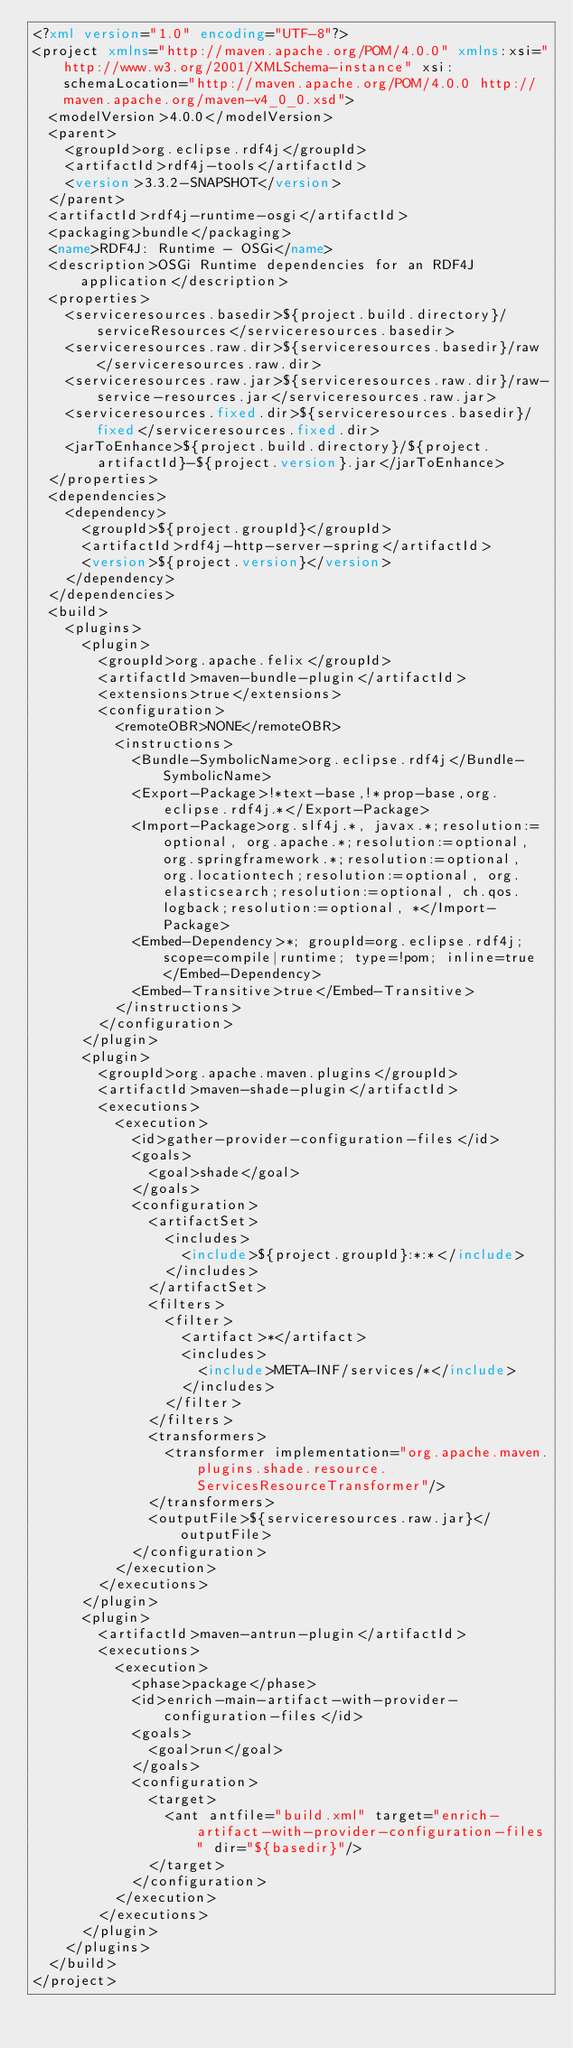Convert code to text. <code><loc_0><loc_0><loc_500><loc_500><_XML_><?xml version="1.0" encoding="UTF-8"?>
<project xmlns="http://maven.apache.org/POM/4.0.0" xmlns:xsi="http://www.w3.org/2001/XMLSchema-instance" xsi:schemaLocation="http://maven.apache.org/POM/4.0.0 http://maven.apache.org/maven-v4_0_0.xsd">
	<modelVersion>4.0.0</modelVersion>
	<parent>
		<groupId>org.eclipse.rdf4j</groupId>
		<artifactId>rdf4j-tools</artifactId>
		<version>3.3.2-SNAPSHOT</version>
	</parent>
	<artifactId>rdf4j-runtime-osgi</artifactId>
	<packaging>bundle</packaging>
	<name>RDF4J: Runtime - OSGi</name>
	<description>OSGi Runtime dependencies for an RDF4J application</description>
	<properties>
		<serviceresources.basedir>${project.build.directory}/serviceResources</serviceresources.basedir>
		<serviceresources.raw.dir>${serviceresources.basedir}/raw</serviceresources.raw.dir>
		<serviceresources.raw.jar>${serviceresources.raw.dir}/raw-service-resources.jar</serviceresources.raw.jar>
		<serviceresources.fixed.dir>${serviceresources.basedir}/fixed</serviceresources.fixed.dir>
		<jarToEnhance>${project.build.directory}/${project.artifactId}-${project.version}.jar</jarToEnhance>
	</properties>
	<dependencies>
		<dependency>
			<groupId>${project.groupId}</groupId>
			<artifactId>rdf4j-http-server-spring</artifactId>
			<version>${project.version}</version>
		</dependency>
	</dependencies>
	<build>
		<plugins>
			<plugin>
				<groupId>org.apache.felix</groupId>
				<artifactId>maven-bundle-plugin</artifactId>
				<extensions>true</extensions>
				<configuration>
					<remoteOBR>NONE</remoteOBR>
					<instructions>
						<Bundle-SymbolicName>org.eclipse.rdf4j</Bundle-SymbolicName>
						<Export-Package>!*text-base,!*prop-base,org.eclipse.rdf4j.*</Export-Package>
						<Import-Package>org.slf4j.*, javax.*;resolution:=optional, org.apache.*;resolution:=optional, org.springframework.*;resolution:=optional, org.locationtech;resolution:=optional, org.elasticsearch;resolution:=optional, ch.qos.logback;resolution:=optional, *</Import-Package>
						<Embed-Dependency>*; groupId=org.eclipse.rdf4j; scope=compile|runtime; type=!pom; inline=true</Embed-Dependency>
						<Embed-Transitive>true</Embed-Transitive>
					</instructions>
				</configuration>
			</plugin>
			<plugin>
				<groupId>org.apache.maven.plugins</groupId>
				<artifactId>maven-shade-plugin</artifactId>
				<executions>
					<execution>
						<id>gather-provider-configuration-files</id>
						<goals>
							<goal>shade</goal>
						</goals>
						<configuration>
							<artifactSet>
								<includes>
									<include>${project.groupId}:*:*</include>
								</includes>
							</artifactSet>
							<filters>
								<filter>
									<artifact>*</artifact>
									<includes>
										<include>META-INF/services/*</include>
									</includes>
								</filter>
							</filters>
							<transformers>
								<transformer implementation="org.apache.maven.plugins.shade.resource.ServicesResourceTransformer"/>
							</transformers>
							<outputFile>${serviceresources.raw.jar}</outputFile>
						</configuration>
					</execution>
				</executions>
			</plugin>
			<plugin>
				<artifactId>maven-antrun-plugin</artifactId>
				<executions>
					<execution>
						<phase>package</phase>
						<id>enrich-main-artifact-with-provider-configuration-files</id>
						<goals>
							<goal>run</goal>
						</goals>
						<configuration>
							<target>
								<ant antfile="build.xml" target="enrich-artifact-with-provider-configuration-files" dir="${basedir}"/>
							</target>
						</configuration>
					</execution>
				</executions>
			</plugin>
		</plugins>
	</build>
</project>
</code> 